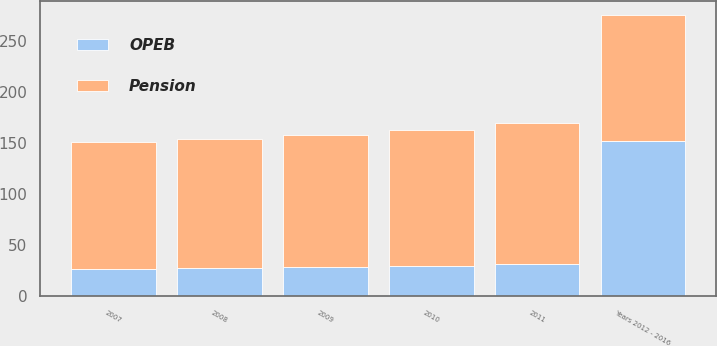Convert chart. <chart><loc_0><loc_0><loc_500><loc_500><stacked_bar_chart><ecel><fcel>2007<fcel>2008<fcel>2009<fcel>2010<fcel>2011<fcel>Years 2012 - 2016<nl><fcel>Pension<fcel>124<fcel>126<fcel>129<fcel>133<fcel>139<fcel>124<nl><fcel>OPEB<fcel>27<fcel>28<fcel>29<fcel>30<fcel>31<fcel>152<nl></chart> 